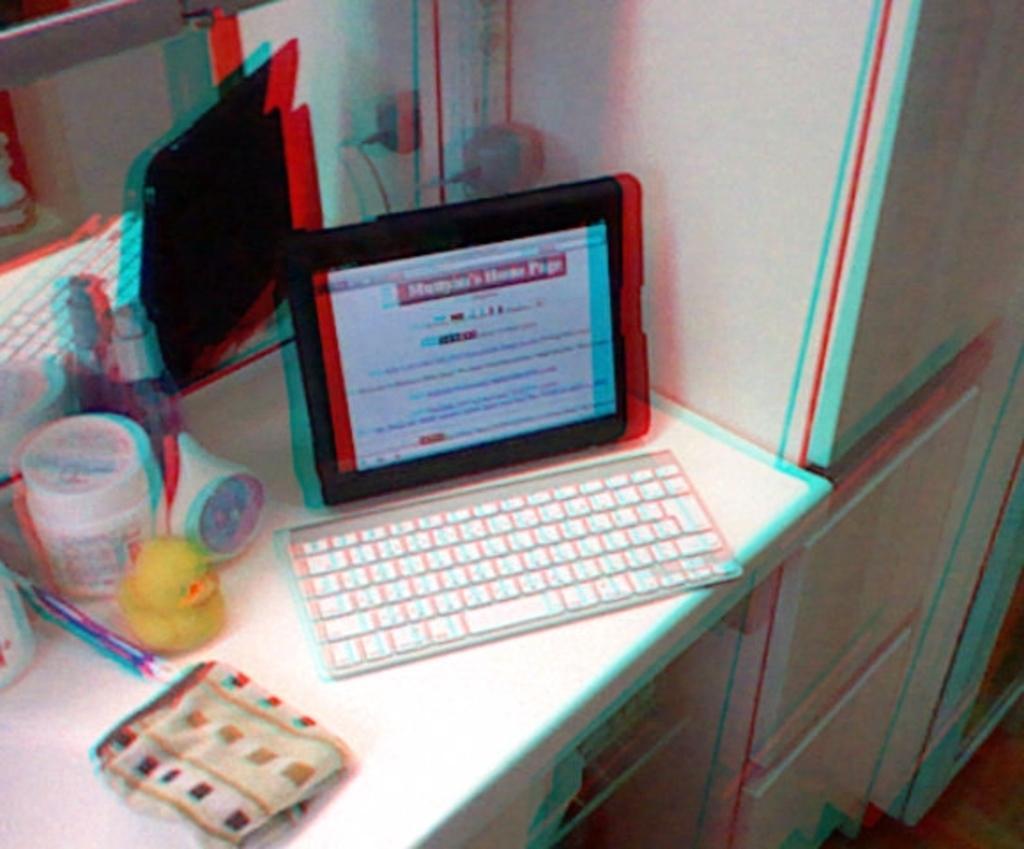Describe this image in one or two sentences. A tablet PC with keyboard and few other articles are placed on a table. 